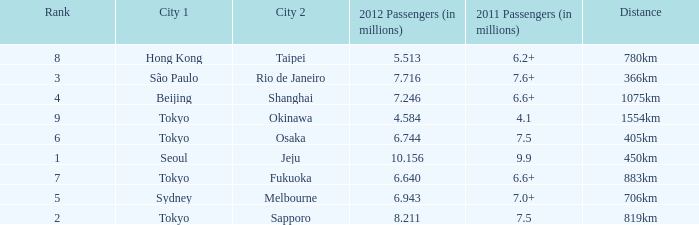How many passengers (in millions) flew through along the route that is 1075km long in 2012? 7.246. 